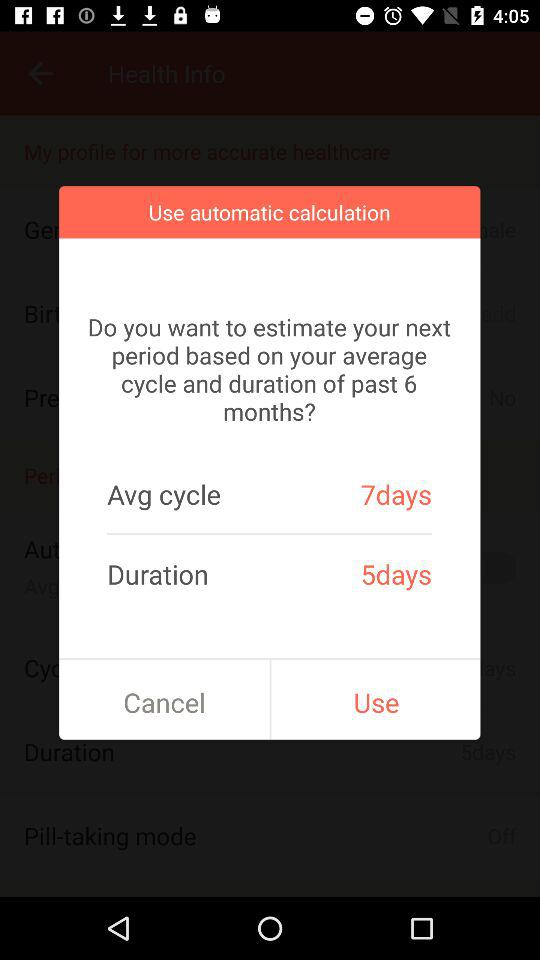What is the duration? The duration is 5 days. 